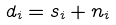Convert formula to latex. <formula><loc_0><loc_0><loc_500><loc_500>d _ { i } = s _ { i } + n _ { i }</formula> 